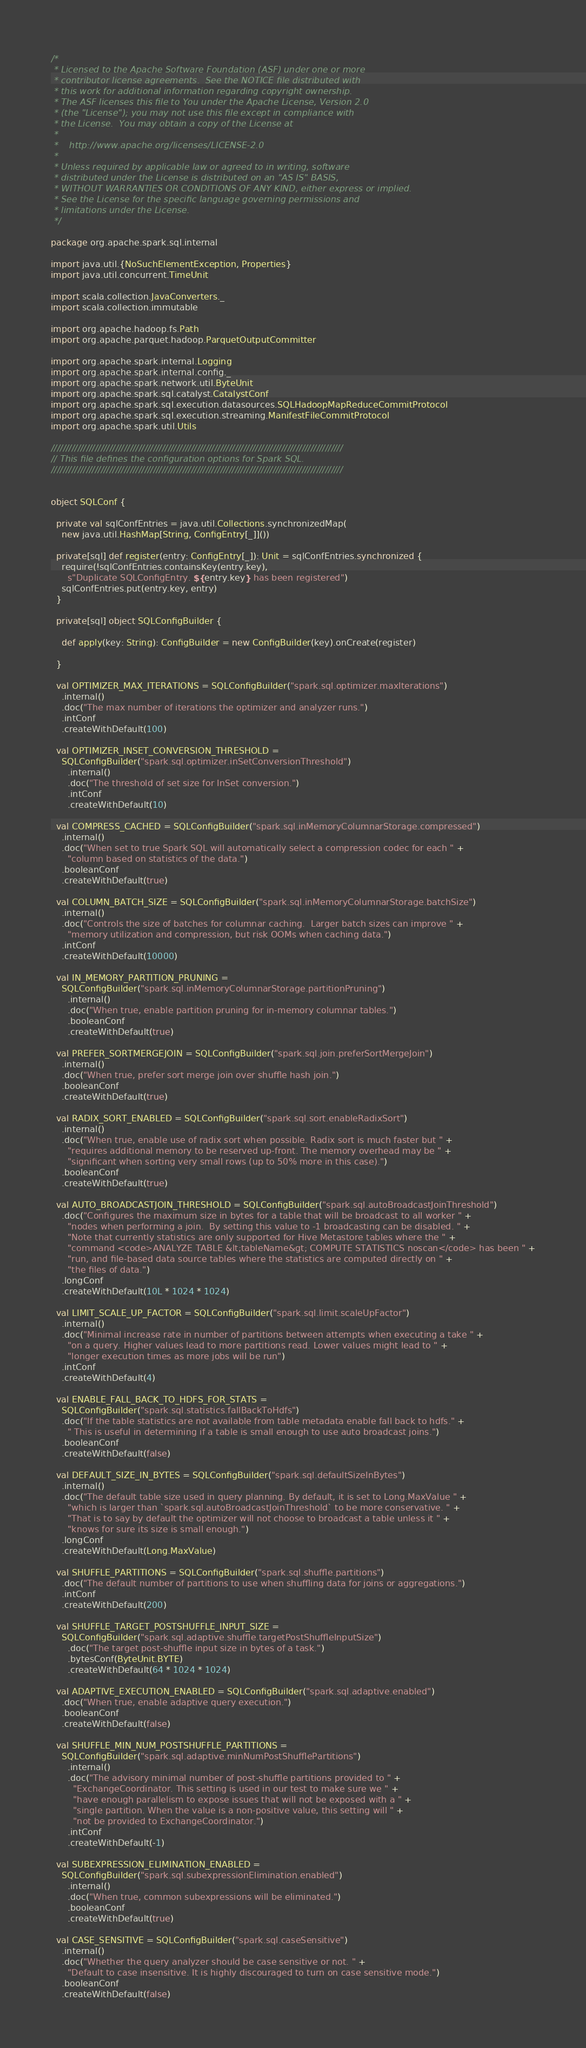Convert code to text. <code><loc_0><loc_0><loc_500><loc_500><_Scala_>/*
 * Licensed to the Apache Software Foundation (ASF) under one or more
 * contributor license agreements.  See the NOTICE file distributed with
 * this work for additional information regarding copyright ownership.
 * The ASF licenses this file to You under the Apache License, Version 2.0
 * (the "License"); you may not use this file except in compliance with
 * the License.  You may obtain a copy of the License at
 *
 *    http://www.apache.org/licenses/LICENSE-2.0
 *
 * Unless required by applicable law or agreed to in writing, software
 * distributed under the License is distributed on an "AS IS" BASIS,
 * WITHOUT WARRANTIES OR CONDITIONS OF ANY KIND, either express or implied.
 * See the License for the specific language governing permissions and
 * limitations under the License.
 */

package org.apache.spark.sql.internal

import java.util.{NoSuchElementException, Properties}
import java.util.concurrent.TimeUnit

import scala.collection.JavaConverters._
import scala.collection.immutable

import org.apache.hadoop.fs.Path
import org.apache.parquet.hadoop.ParquetOutputCommitter

import org.apache.spark.internal.Logging
import org.apache.spark.internal.config._
import org.apache.spark.network.util.ByteUnit
import org.apache.spark.sql.catalyst.CatalystConf
import org.apache.spark.sql.execution.datasources.SQLHadoopMapReduceCommitProtocol
import org.apache.spark.sql.execution.streaming.ManifestFileCommitProtocol
import org.apache.spark.util.Utils

////////////////////////////////////////////////////////////////////////////////////////////////////
// This file defines the configuration options for Spark SQL.
////////////////////////////////////////////////////////////////////////////////////////////////////


object SQLConf {

  private val sqlConfEntries = java.util.Collections.synchronizedMap(
    new java.util.HashMap[String, ConfigEntry[_]]())

  private[sql] def register(entry: ConfigEntry[_]): Unit = sqlConfEntries.synchronized {
    require(!sqlConfEntries.containsKey(entry.key),
      s"Duplicate SQLConfigEntry. ${entry.key} has been registered")
    sqlConfEntries.put(entry.key, entry)
  }

  private[sql] object SQLConfigBuilder {

    def apply(key: String): ConfigBuilder = new ConfigBuilder(key).onCreate(register)

  }

  val OPTIMIZER_MAX_ITERATIONS = SQLConfigBuilder("spark.sql.optimizer.maxIterations")
    .internal()
    .doc("The max number of iterations the optimizer and analyzer runs.")
    .intConf
    .createWithDefault(100)

  val OPTIMIZER_INSET_CONVERSION_THRESHOLD =
    SQLConfigBuilder("spark.sql.optimizer.inSetConversionThreshold")
      .internal()
      .doc("The threshold of set size for InSet conversion.")
      .intConf
      .createWithDefault(10)

  val COMPRESS_CACHED = SQLConfigBuilder("spark.sql.inMemoryColumnarStorage.compressed")
    .internal()
    .doc("When set to true Spark SQL will automatically select a compression codec for each " +
      "column based on statistics of the data.")
    .booleanConf
    .createWithDefault(true)

  val COLUMN_BATCH_SIZE = SQLConfigBuilder("spark.sql.inMemoryColumnarStorage.batchSize")
    .internal()
    .doc("Controls the size of batches for columnar caching.  Larger batch sizes can improve " +
      "memory utilization and compression, but risk OOMs when caching data.")
    .intConf
    .createWithDefault(10000)

  val IN_MEMORY_PARTITION_PRUNING =
    SQLConfigBuilder("spark.sql.inMemoryColumnarStorage.partitionPruning")
      .internal()
      .doc("When true, enable partition pruning for in-memory columnar tables.")
      .booleanConf
      .createWithDefault(true)

  val PREFER_SORTMERGEJOIN = SQLConfigBuilder("spark.sql.join.preferSortMergeJoin")
    .internal()
    .doc("When true, prefer sort merge join over shuffle hash join.")
    .booleanConf
    .createWithDefault(true)

  val RADIX_SORT_ENABLED = SQLConfigBuilder("spark.sql.sort.enableRadixSort")
    .internal()
    .doc("When true, enable use of radix sort when possible. Radix sort is much faster but " +
      "requires additional memory to be reserved up-front. The memory overhead may be " +
      "significant when sorting very small rows (up to 50% more in this case).")
    .booleanConf
    .createWithDefault(true)

  val AUTO_BROADCASTJOIN_THRESHOLD = SQLConfigBuilder("spark.sql.autoBroadcastJoinThreshold")
    .doc("Configures the maximum size in bytes for a table that will be broadcast to all worker " +
      "nodes when performing a join.  By setting this value to -1 broadcasting can be disabled. " +
      "Note that currently statistics are only supported for Hive Metastore tables where the " +
      "command <code>ANALYZE TABLE &lt;tableName&gt; COMPUTE STATISTICS noscan</code> has been " +
      "run, and file-based data source tables where the statistics are computed directly on " +
      "the files of data.")
    .longConf
    .createWithDefault(10L * 1024 * 1024)

  val LIMIT_SCALE_UP_FACTOR = SQLConfigBuilder("spark.sql.limit.scaleUpFactor")
    .internal()
    .doc("Minimal increase rate in number of partitions between attempts when executing a take " +
      "on a query. Higher values lead to more partitions read. Lower values might lead to " +
      "longer execution times as more jobs will be run")
    .intConf
    .createWithDefault(4)

  val ENABLE_FALL_BACK_TO_HDFS_FOR_STATS =
    SQLConfigBuilder("spark.sql.statistics.fallBackToHdfs")
    .doc("If the table statistics are not available from table metadata enable fall back to hdfs." +
      " This is useful in determining if a table is small enough to use auto broadcast joins.")
    .booleanConf
    .createWithDefault(false)

  val DEFAULT_SIZE_IN_BYTES = SQLConfigBuilder("spark.sql.defaultSizeInBytes")
    .internal()
    .doc("The default table size used in query planning. By default, it is set to Long.MaxValue " +
      "which is larger than `spark.sql.autoBroadcastJoinThreshold` to be more conservative. " +
      "That is to say by default the optimizer will not choose to broadcast a table unless it " +
      "knows for sure its size is small enough.")
    .longConf
    .createWithDefault(Long.MaxValue)

  val SHUFFLE_PARTITIONS = SQLConfigBuilder("spark.sql.shuffle.partitions")
    .doc("The default number of partitions to use when shuffling data for joins or aggregations.")
    .intConf
    .createWithDefault(200)

  val SHUFFLE_TARGET_POSTSHUFFLE_INPUT_SIZE =
    SQLConfigBuilder("spark.sql.adaptive.shuffle.targetPostShuffleInputSize")
      .doc("The target post-shuffle input size in bytes of a task.")
      .bytesConf(ByteUnit.BYTE)
      .createWithDefault(64 * 1024 * 1024)

  val ADAPTIVE_EXECUTION_ENABLED = SQLConfigBuilder("spark.sql.adaptive.enabled")
    .doc("When true, enable adaptive query execution.")
    .booleanConf
    .createWithDefault(false)

  val SHUFFLE_MIN_NUM_POSTSHUFFLE_PARTITIONS =
    SQLConfigBuilder("spark.sql.adaptive.minNumPostShufflePartitions")
      .internal()
      .doc("The advisory minimal number of post-shuffle partitions provided to " +
        "ExchangeCoordinator. This setting is used in our test to make sure we " +
        "have enough parallelism to expose issues that will not be exposed with a " +
        "single partition. When the value is a non-positive value, this setting will " +
        "not be provided to ExchangeCoordinator.")
      .intConf
      .createWithDefault(-1)

  val SUBEXPRESSION_ELIMINATION_ENABLED =
    SQLConfigBuilder("spark.sql.subexpressionElimination.enabled")
      .internal()
      .doc("When true, common subexpressions will be eliminated.")
      .booleanConf
      .createWithDefault(true)

  val CASE_SENSITIVE = SQLConfigBuilder("spark.sql.caseSensitive")
    .internal()
    .doc("Whether the query analyzer should be case sensitive or not. " +
      "Default to case insensitive. It is highly discouraged to turn on case sensitive mode.")
    .booleanConf
    .createWithDefault(false)
</code> 